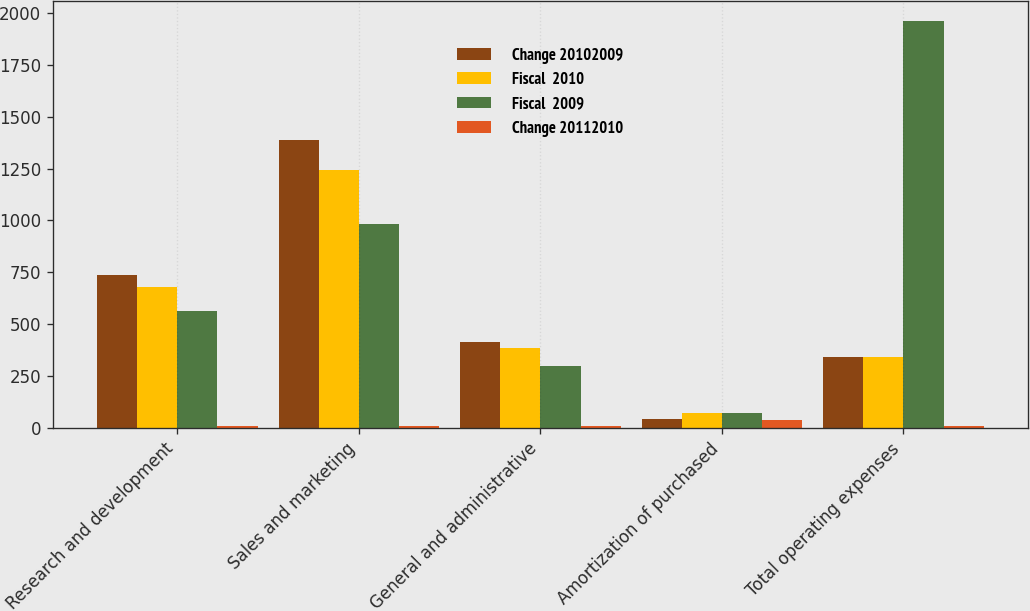Convert chart. <chart><loc_0><loc_0><loc_500><loc_500><stacked_bar_chart><ecel><fcel>Research and development<fcel>Sales and marketing<fcel>General and administrative<fcel>Amortization of purchased<fcel>Total operating expenses<nl><fcel>Change 20102009<fcel>738.1<fcel>1385.8<fcel>414.6<fcel>42.8<fcel>341.1<nl><fcel>Fiscal  2010<fcel>680.3<fcel>1244.2<fcel>383.5<fcel>72.1<fcel>341.1<nl><fcel>Fiscal  2009<fcel>565.1<fcel>981.9<fcel>298.7<fcel>71.6<fcel>1958.6<nl><fcel>Change 20112010<fcel>8<fcel>11<fcel>8<fcel>41<fcel>11<nl></chart> 